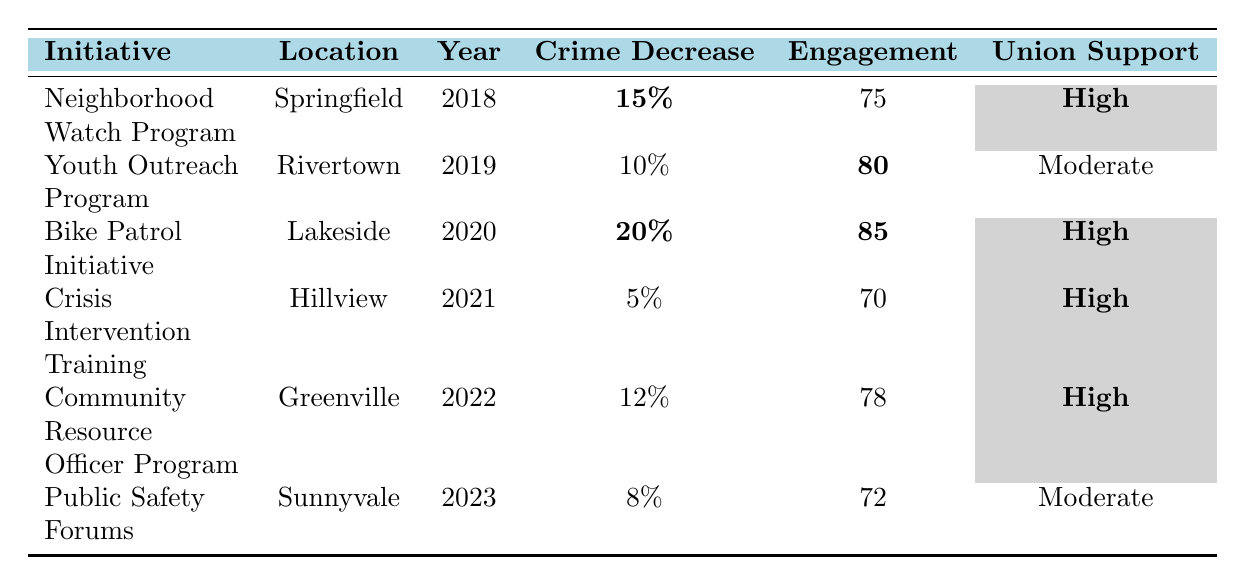What initiative had the highest reported crime decrease? The 'Bike Patrol Initiative' reported a crime decrease of 20%, which is the highest in the table compared to other initiatives.
Answer: Bike Patrol Initiative In which year was the 'Community Resource Officer Program' launched? According to the table, the 'Community Resource Officer Program' was launched in the year 2022.
Answer: 2022 What is the community engagement score of the 'Youth Outreach Program'? The table states that the community engagement score for the 'Youth Outreach Program' is 80.
Answer: 80 Which initiatives have high police union support? The initiatives with high police union support are: 'Neighborhood Watch Program', 'Bike Patrol Initiative', 'Crisis Intervention Training', and 'Community Resource Officer Program'.
Answer: 4 initiatives What is the average community engagement score for initiatives launched in 2021 and later? The scores for initiatives launched in 2021 and later are 70 (Crisis Intervention Training), 78 (Community Resource Officer Program), and 72 (Public Safety Forums). Thus, the average is (70 + 78 + 72) / 3 = 220 / 3 = approximately 73.33.
Answer: 73.33 Did the 'Public Safety Forums' have a higher community engagement score than the 'Crisis Intervention Training'? The 'Public Safety Forums' have a community engagement score of 72, while the 'Crisis Intervention Training' has a score of 70. Therefore, yes, the Public Safety Forums had a higher score.
Answer: Yes What is the difference in reported crime decrease between the 'Neighborhood Watch Program' and the 'Crisis Intervention Training'? The 'Neighborhood Watch Program' had a reported crime decrease of 15%, and the 'Crisis Intervention Training' had a decrease of 5%. The difference is 15% - 5% = 10%.
Answer: 10% Which location had the highest community engagement score? The 'Bike Patrol Initiative' located in Lakeside had the highest community engagement score of 85 among all listed initiatives.
Answer: Lakeside Is there any initiative launched in 2023 with moderate police union support? Yes, the 'Public Safety Forums' initiative was launched in 2023 and has moderate police union support.
Answer: Yes 